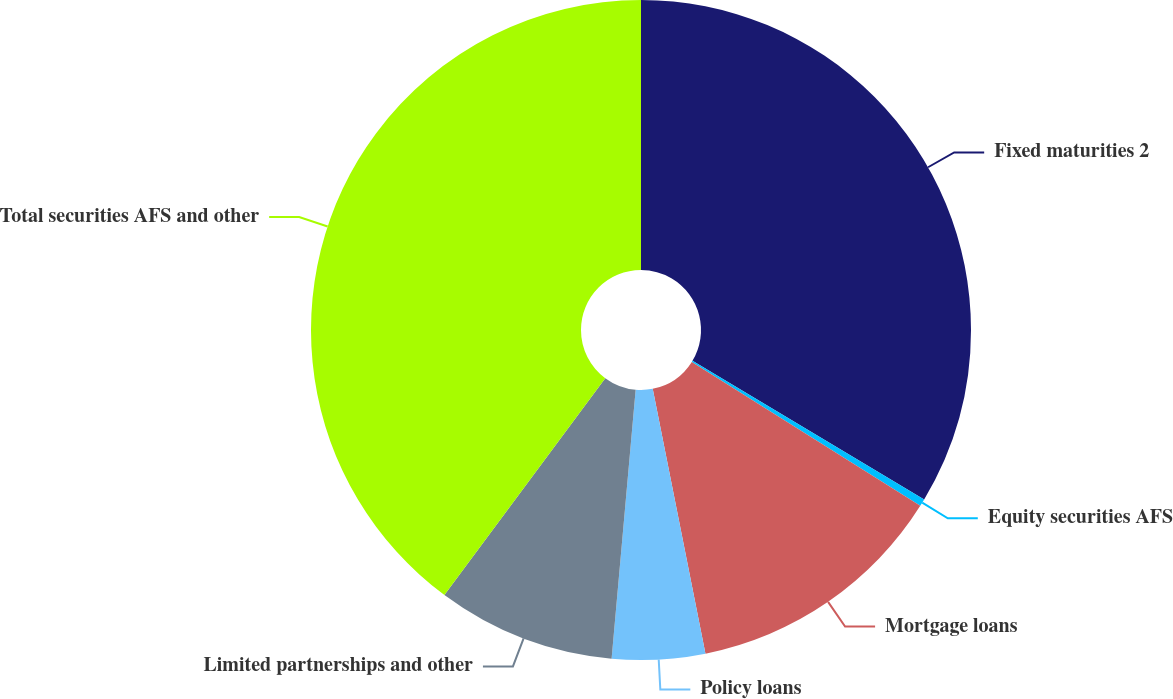Convert chart to OTSL. <chart><loc_0><loc_0><loc_500><loc_500><pie_chart><fcel>Fixed maturities 2<fcel>Equity securities AFS<fcel>Mortgage loans<fcel>Policy loans<fcel>Limited partnerships and other<fcel>Total securities AFS and other<nl><fcel>33.59%<fcel>0.36%<fcel>12.93%<fcel>4.55%<fcel>8.74%<fcel>39.85%<nl></chart> 